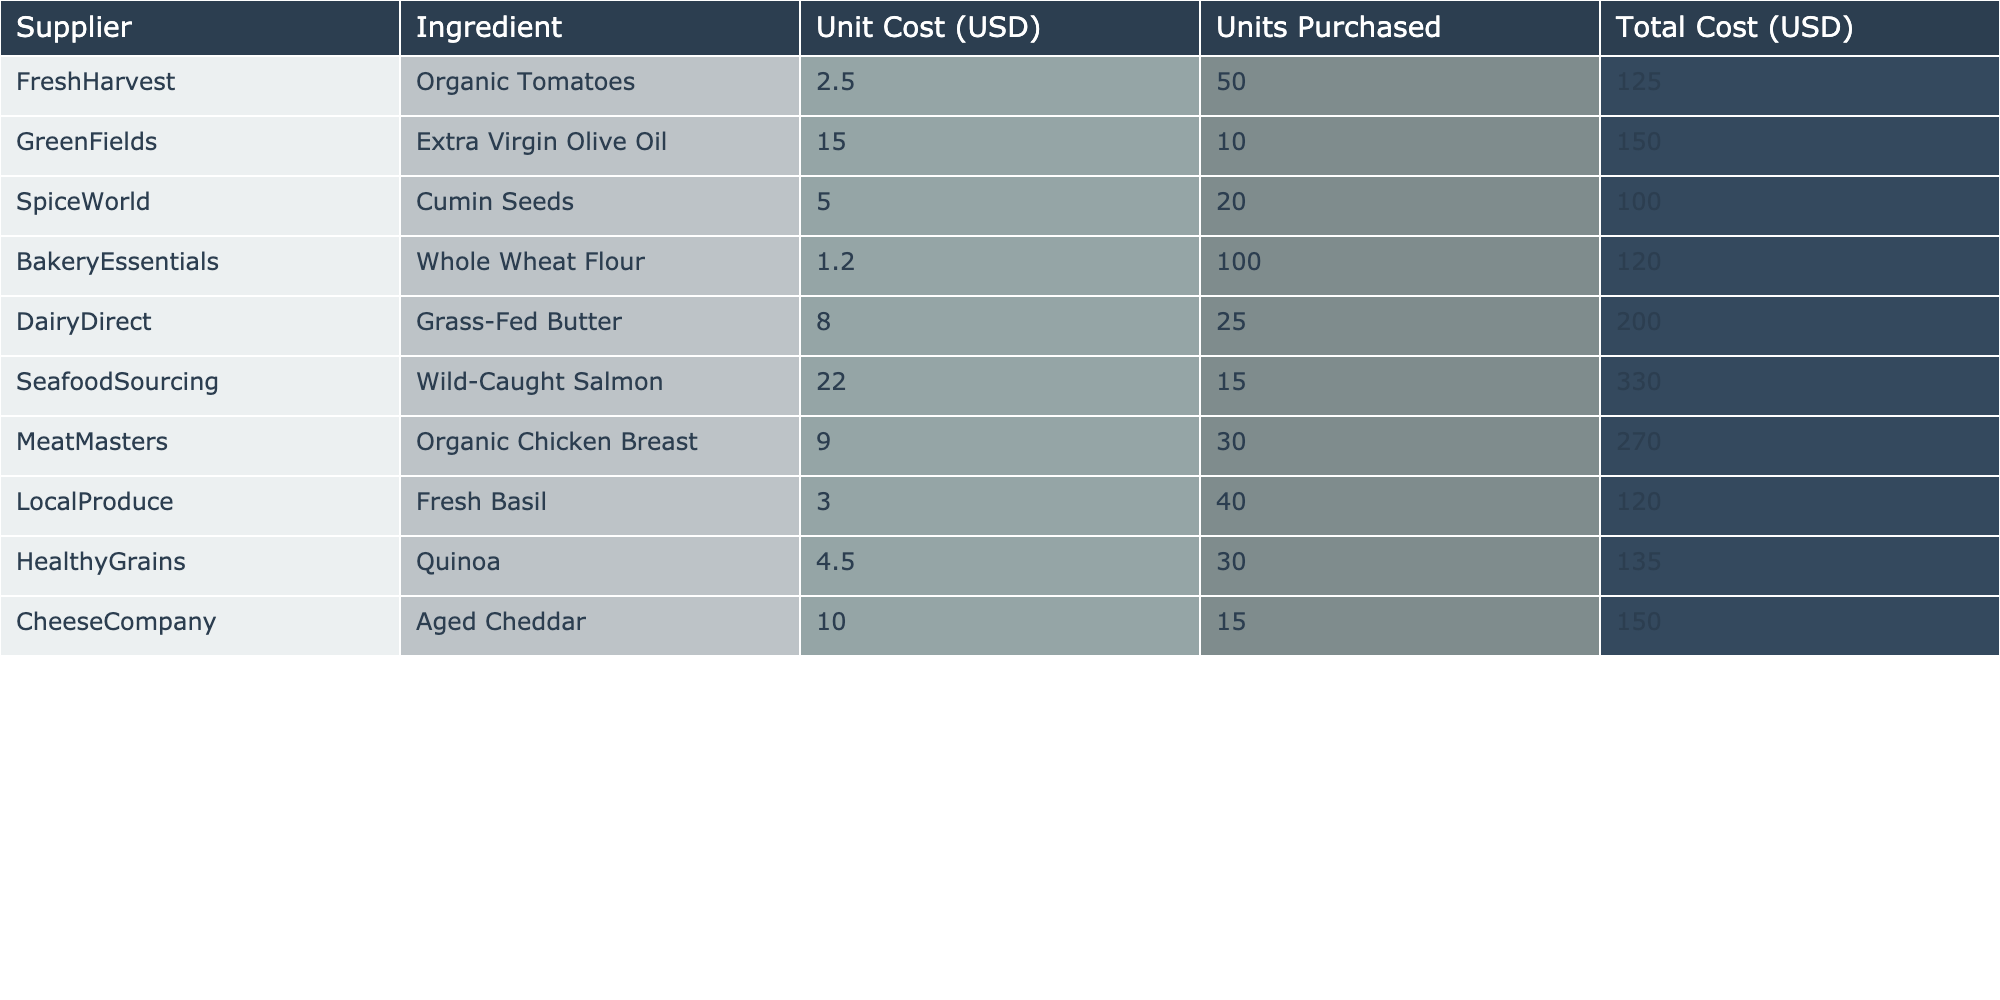What is the total cost for DairyDirect? The total cost for DairyDirect is listed directly in the table, which shows a value of 200.00 USD for Grass-Fed Butter.
Answer: 200.00 USD Which ingredient has the highest unit cost? Looking through the "Unit Cost (USD)" column, the highest value is 22.00, corresponding to Wild-Caught Salmon from SeafoodSourcing.
Answer: Wild-Caught Salmon What is the combined total cost for all ingredients from FreshHarvest and GreenFields? We find the total cost for FreshHarvest (125.00) and GreenFields (150.00), then add these values: 125.00 + 150.00 = 275.00.
Answer: 275.00 How many units of Organic Chicken Breast were purchased? The table shows that 30 units of Organic Chicken Breast were purchased from MeatMasters.
Answer: 30 units Is the total cost for Whole Wheat Flour greater than for Extra Virgin Olive Oil? The total cost for Whole Wheat Flour is 120.00 and for Extra Virgin Olive Oil is 150.00. Since 120.00 is less than 150.00, the statement is false.
Answer: No What is the average unit cost of all ingredients listed? To find the average, sum all unit costs (2.50 + 15.00 + 5.00 + 1.20 + 8.00 + 22.00 + 9.00 + 3.00 + 4.50 + 10.00) = 76.20. Then, divide by the number of ingredients (10): 76.20 / 10 = 7.62.
Answer: 7.62 Which supplier provides the lowest total cost? By checking the total costs in the table, BakeryEssentials has the lowest total cost of 120.00 for Whole Wheat Flour.
Answer: BakeryEssentials What is the total expenditure on Seafood ingredients? The only seafood ingredient listed is Wild-Caught Salmon, costing 330.00.
Answer: 330.00 If I purchased 5 fewer units of Organic Tomatoes, what would be the new total cost? The current total cost for Organic Tomatoes is 125.00. If 5 fewer units (i.e., 50 - 5 = 45 units) were purchased, the new total cost would be 2.50 * 45 = 112.50.
Answer: 112.50 Which ingredient accounts for the highest total cost? Reviewing the "Total Cost (USD)" column, Wild-Caught Salmon at 330.00 is the highest total cost.
Answer: Wild-Caught Salmon 